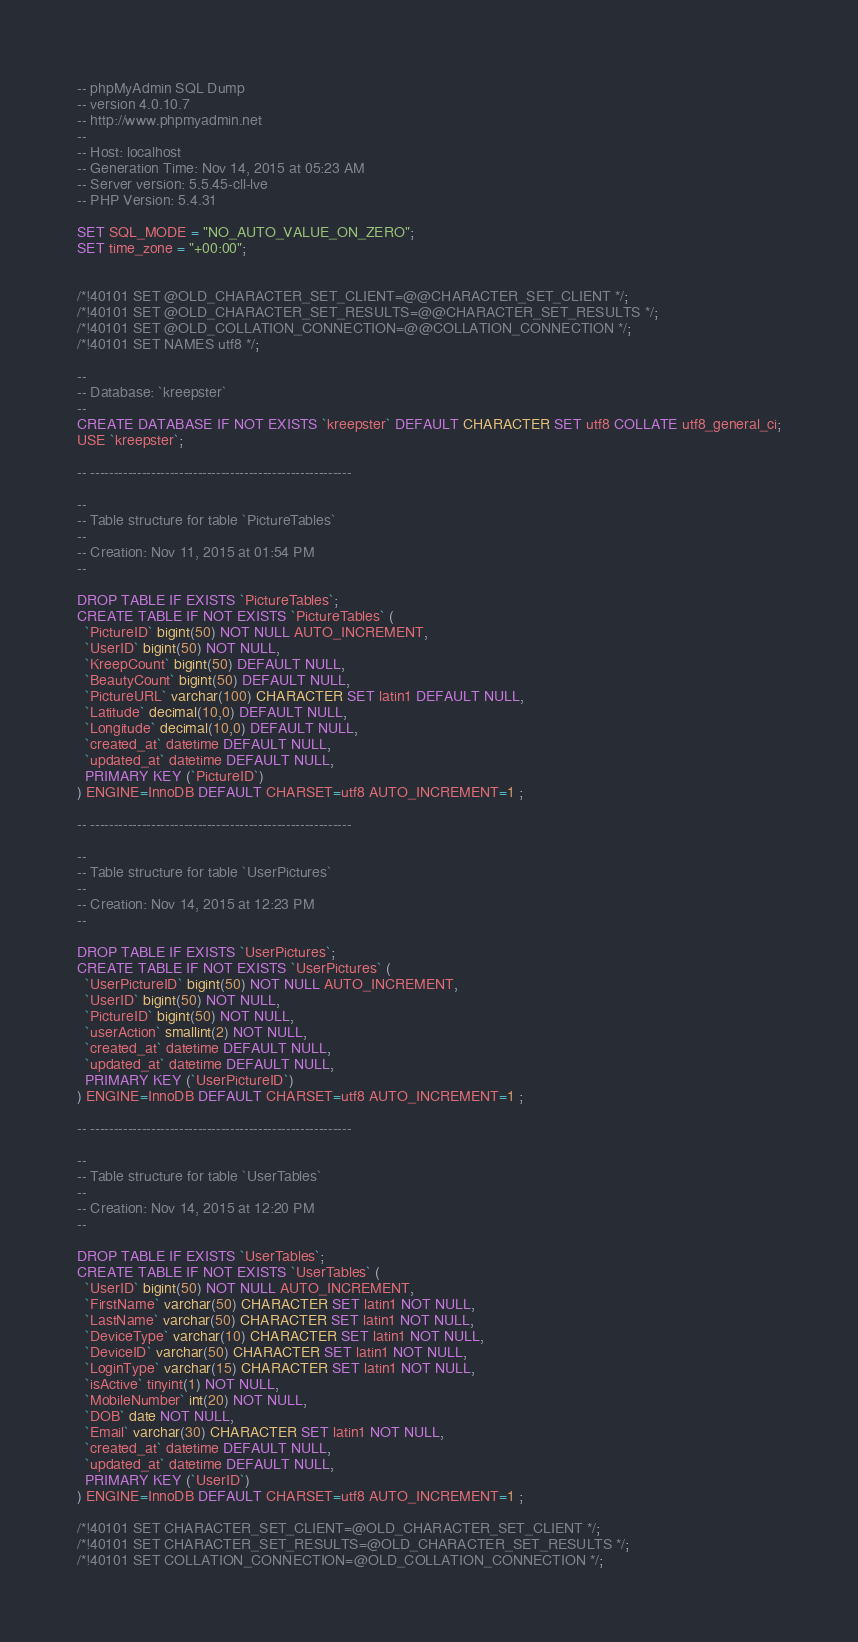Convert code to text. <code><loc_0><loc_0><loc_500><loc_500><_SQL_>-- phpMyAdmin SQL Dump
-- version 4.0.10.7
-- http://www.phpmyadmin.net
--
-- Host: localhost
-- Generation Time: Nov 14, 2015 at 05:23 AM
-- Server version: 5.5.45-cll-lve
-- PHP Version: 5.4.31

SET SQL_MODE = "NO_AUTO_VALUE_ON_ZERO";
SET time_zone = "+00:00";


/*!40101 SET @OLD_CHARACTER_SET_CLIENT=@@CHARACTER_SET_CLIENT */;
/*!40101 SET @OLD_CHARACTER_SET_RESULTS=@@CHARACTER_SET_RESULTS */;
/*!40101 SET @OLD_COLLATION_CONNECTION=@@COLLATION_CONNECTION */;
/*!40101 SET NAMES utf8 */;

--
-- Database: `kreepster`
--
CREATE DATABASE IF NOT EXISTS `kreepster` DEFAULT CHARACTER SET utf8 COLLATE utf8_general_ci;
USE `kreepster`;

-- --------------------------------------------------------

--
-- Table structure for table `PictureTables`
--
-- Creation: Nov 11, 2015 at 01:54 PM
--

DROP TABLE IF EXISTS `PictureTables`;
CREATE TABLE IF NOT EXISTS `PictureTables` (
  `PictureID` bigint(50) NOT NULL AUTO_INCREMENT,
  `UserID` bigint(50) NOT NULL,
  `KreepCount` bigint(50) DEFAULT NULL,
  `BeautyCount` bigint(50) DEFAULT NULL,
  `PictureURL` varchar(100) CHARACTER SET latin1 DEFAULT NULL,
  `Latitude` decimal(10,0) DEFAULT NULL,
  `Longitude` decimal(10,0) DEFAULT NULL,
  `created_at` datetime DEFAULT NULL,
  `updated_at` datetime DEFAULT NULL,
  PRIMARY KEY (`PictureID`)
) ENGINE=InnoDB DEFAULT CHARSET=utf8 AUTO_INCREMENT=1 ;

-- --------------------------------------------------------

--
-- Table structure for table `UserPictures`
--
-- Creation: Nov 14, 2015 at 12:23 PM
--

DROP TABLE IF EXISTS `UserPictures`;
CREATE TABLE IF NOT EXISTS `UserPictures` (
  `UserPictureID` bigint(50) NOT NULL AUTO_INCREMENT,
  `UserID` bigint(50) NOT NULL,
  `PictureID` bigint(50) NOT NULL,
  `userAction` smallint(2) NOT NULL,
  `created_at` datetime DEFAULT NULL,
  `updated_at` datetime DEFAULT NULL,
  PRIMARY KEY (`UserPictureID`)
) ENGINE=InnoDB DEFAULT CHARSET=utf8 AUTO_INCREMENT=1 ;

-- --------------------------------------------------------

--
-- Table structure for table `UserTables`
--
-- Creation: Nov 14, 2015 at 12:20 PM
--

DROP TABLE IF EXISTS `UserTables`;
CREATE TABLE IF NOT EXISTS `UserTables` (
  `UserID` bigint(50) NOT NULL AUTO_INCREMENT,
  `FirstName` varchar(50) CHARACTER SET latin1 NOT NULL,
  `LastName` varchar(50) CHARACTER SET latin1 NOT NULL,
  `DeviceType` varchar(10) CHARACTER SET latin1 NOT NULL,
  `DeviceID` varchar(50) CHARACTER SET latin1 NOT NULL,
  `LoginType` varchar(15) CHARACTER SET latin1 NOT NULL,
  `isActive` tinyint(1) NOT NULL,
  `MobileNumber` int(20) NOT NULL,
  `DOB` date NOT NULL,
  `Email` varchar(30) CHARACTER SET latin1 NOT NULL,
  `created_at` datetime DEFAULT NULL,
  `updated_at` datetime DEFAULT NULL,
  PRIMARY KEY (`UserID`)
) ENGINE=InnoDB DEFAULT CHARSET=utf8 AUTO_INCREMENT=1 ;

/*!40101 SET CHARACTER_SET_CLIENT=@OLD_CHARACTER_SET_CLIENT */;
/*!40101 SET CHARACTER_SET_RESULTS=@OLD_CHARACTER_SET_RESULTS */;
/*!40101 SET COLLATION_CONNECTION=@OLD_COLLATION_CONNECTION */;
</code> 